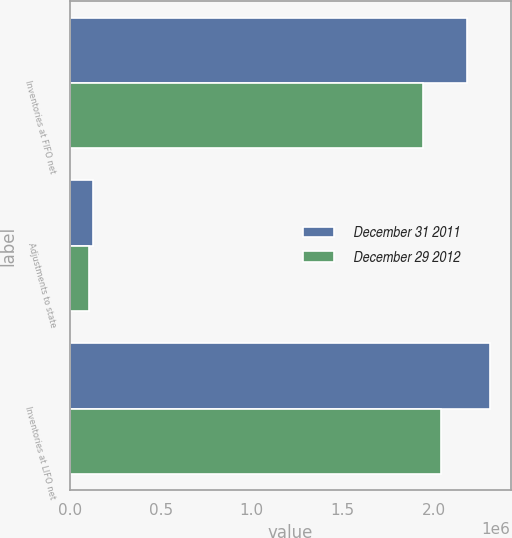Convert chart to OTSL. <chart><loc_0><loc_0><loc_500><loc_500><stacked_bar_chart><ecel><fcel>Inventories at FIFO net<fcel>Adjustments to state<fcel>Inventories at LIFO net<nl><fcel>December 31 2011<fcel>2.18242e+06<fcel>126190<fcel>2.30861e+06<nl><fcel>December 29 2012<fcel>1.94106e+06<fcel>102103<fcel>2.04316e+06<nl></chart> 